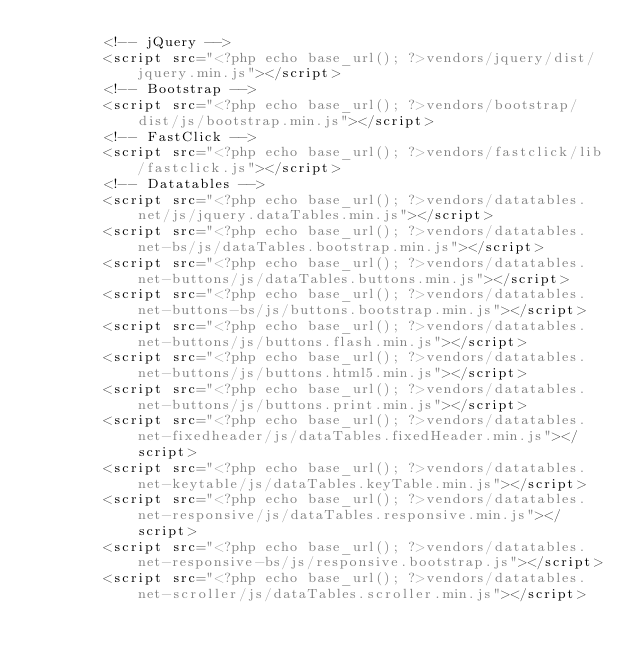<code> <loc_0><loc_0><loc_500><loc_500><_PHP_>        <!-- jQuery -->
        <script src="<?php echo base_url(); ?>vendors/jquery/dist/jquery.min.js"></script>
        <!-- Bootstrap -->
        <script src="<?php echo base_url(); ?>vendors/bootstrap/dist/js/bootstrap.min.js"></script>
        <!-- FastClick -->
        <script src="<?php echo base_url(); ?>vendors/fastclick/lib/fastclick.js"></script>
        <!-- Datatables -->
        <script src="<?php echo base_url(); ?>vendors/datatables.net/js/jquery.dataTables.min.js"></script>
        <script src="<?php echo base_url(); ?>vendors/datatables.net-bs/js/dataTables.bootstrap.min.js"></script>
        <script src="<?php echo base_url(); ?>vendors/datatables.net-buttons/js/dataTables.buttons.min.js"></script>
        <script src="<?php echo base_url(); ?>vendors/datatables.net-buttons-bs/js/buttons.bootstrap.min.js"></script>
        <script src="<?php echo base_url(); ?>vendors/datatables.net-buttons/js/buttons.flash.min.js"></script>
        <script src="<?php echo base_url(); ?>vendors/datatables.net-buttons/js/buttons.html5.min.js"></script>
        <script src="<?php echo base_url(); ?>vendors/datatables.net-buttons/js/buttons.print.min.js"></script>
        <script src="<?php echo base_url(); ?>vendors/datatables.net-fixedheader/js/dataTables.fixedHeader.min.js"></script>
        <script src="<?php echo base_url(); ?>vendors/datatables.net-keytable/js/dataTables.keyTable.min.js"></script>
        <script src="<?php echo base_url(); ?>vendors/datatables.net-responsive/js/dataTables.responsive.min.js"></script>
        <script src="<?php echo base_url(); ?>vendors/datatables.net-responsive-bs/js/responsive.bootstrap.js"></script>
        <script src="<?php echo base_url(); ?>vendors/datatables.net-scroller/js/dataTables.scroller.min.js"></script></code> 